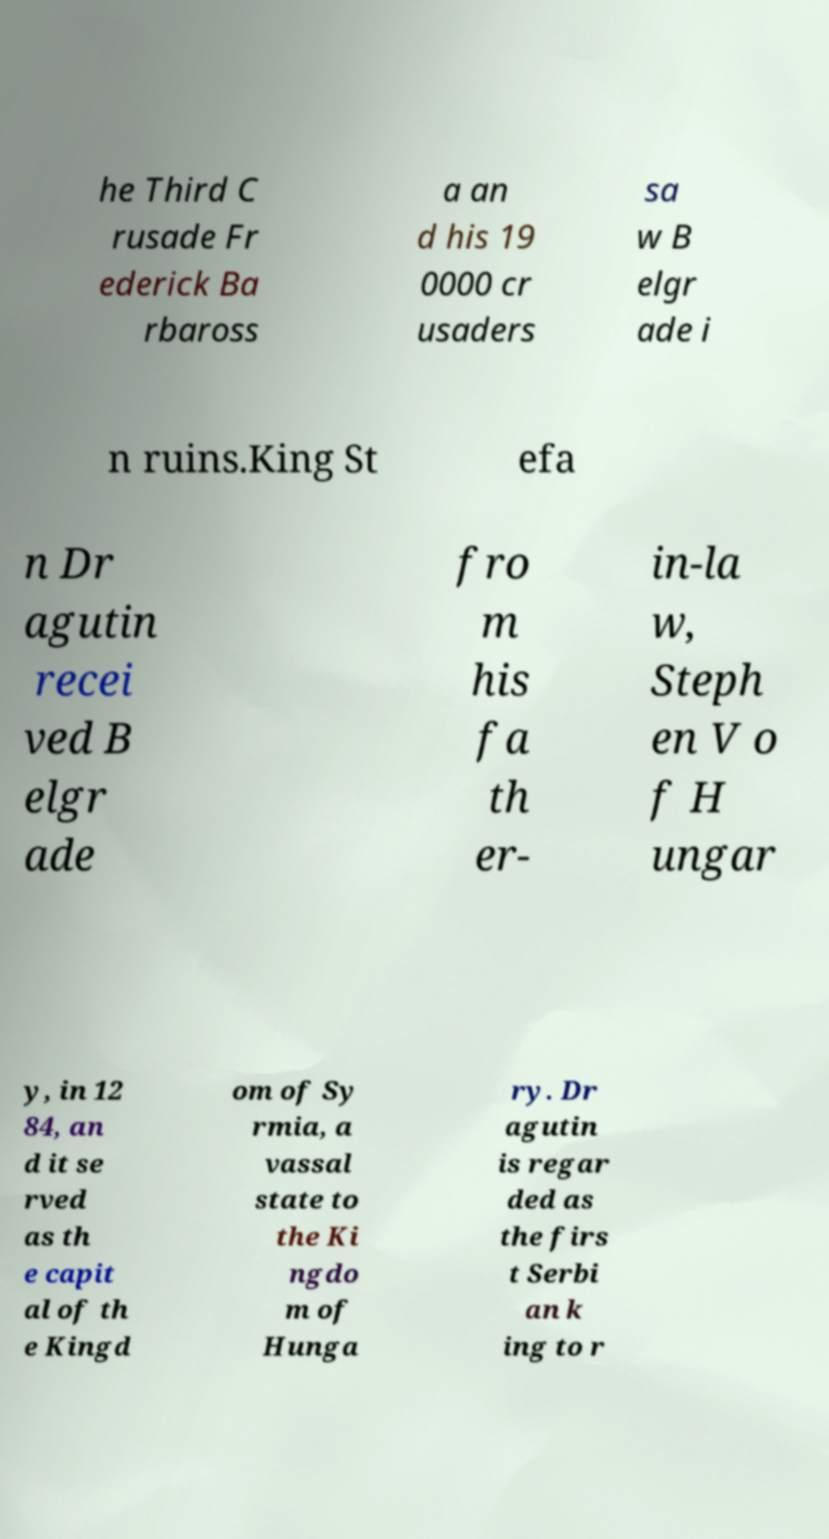Please read and relay the text visible in this image. What does it say? he Third C rusade Fr ederick Ba rbaross a an d his 19 0000 cr usaders sa w B elgr ade i n ruins.King St efa n Dr agutin recei ved B elgr ade fro m his fa th er- in-la w, Steph en V o f H ungar y, in 12 84, an d it se rved as th e capit al of th e Kingd om of Sy rmia, a vassal state to the Ki ngdo m of Hunga ry. Dr agutin is regar ded as the firs t Serbi an k ing to r 